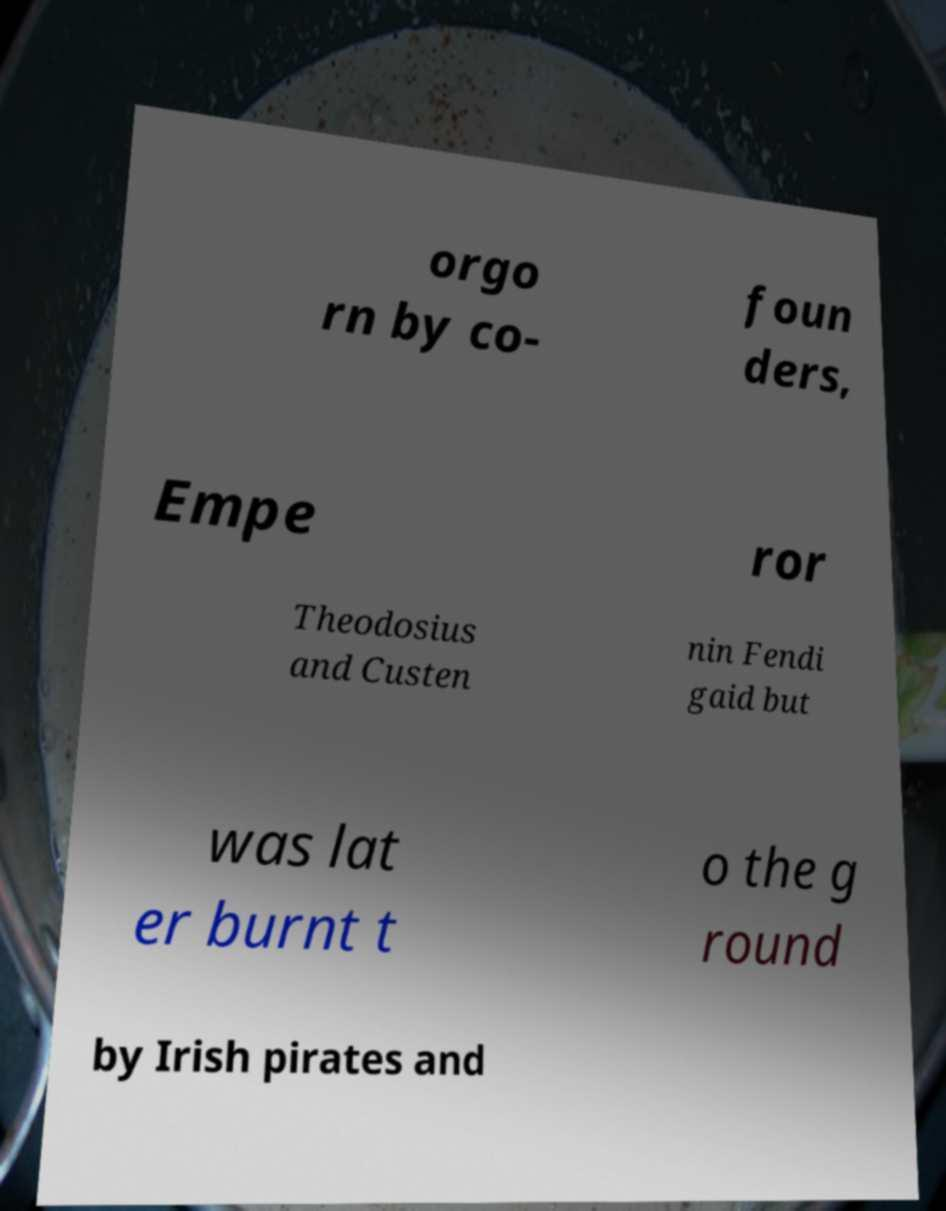For documentation purposes, I need the text within this image transcribed. Could you provide that? orgo rn by co- foun ders, Empe ror Theodosius and Custen nin Fendi gaid but was lat er burnt t o the g round by Irish pirates and 